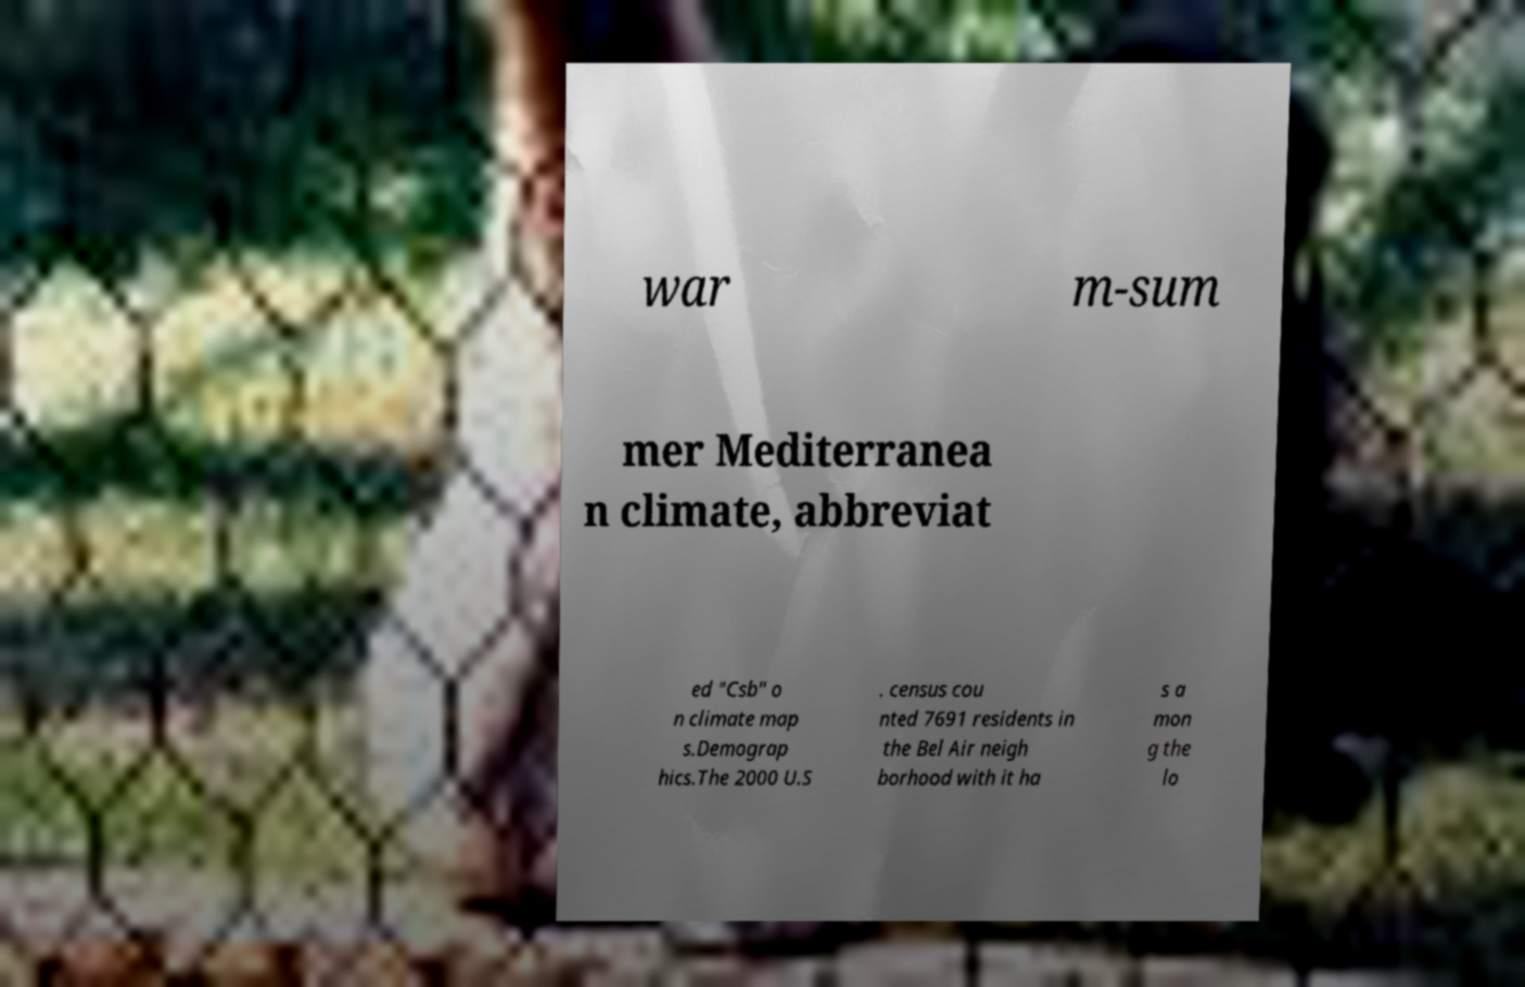There's text embedded in this image that I need extracted. Can you transcribe it verbatim? war m-sum mer Mediterranea n climate, abbreviat ed "Csb" o n climate map s.Demograp hics.The 2000 U.S . census cou nted 7691 residents in the Bel Air neigh borhood with it ha s a mon g the lo 